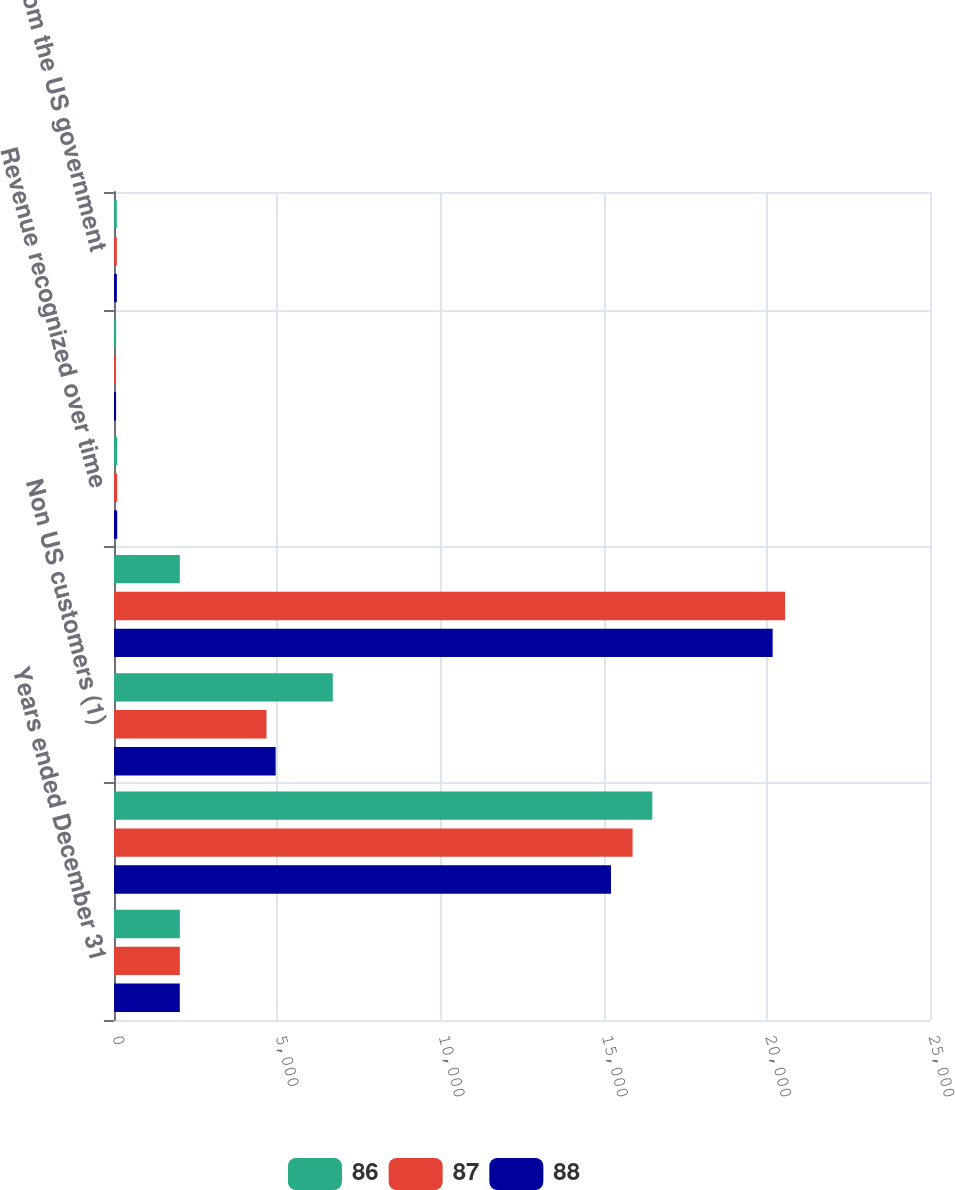Convert chart. <chart><loc_0><loc_0><loc_500><loc_500><stacked_bar_chart><ecel><fcel>Years ended December 31<fcel>US customers<fcel>Non US customers (1)<fcel>Total segment revenue from<fcel>Revenue recognized over time<fcel>Revenue recognized on<fcel>Revenue from the US government<nl><fcel>86<fcel>2018<fcel>16492<fcel>6703<fcel>2016.5<fcel>98<fcel>65<fcel>86<nl><fcel>87<fcel>2017<fcel>15889<fcel>4672<fcel>20561<fcel>97<fcel>63<fcel>87<nl><fcel>88<fcel>2016<fcel>15227<fcel>4953<fcel>20180<fcel>99<fcel>64<fcel>88<nl></chart> 